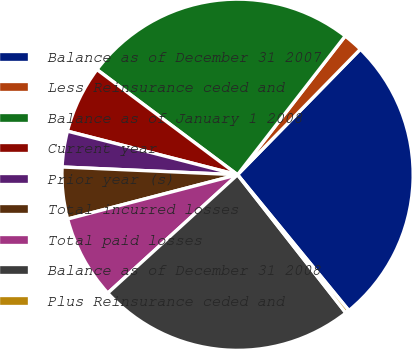Convert chart to OTSL. <chart><loc_0><loc_0><loc_500><loc_500><pie_chart><fcel>Balance as of December 31 2007<fcel>Less Reinsurance ceded and<fcel>Balance as of January 1 2008<fcel>Current year<fcel>Prior year (s)<fcel>Total incurred losses<fcel>Total paid losses<fcel>Balance as of December 31 2008<fcel>Plus Reinsurance ceded and<nl><fcel>26.75%<fcel>1.82%<fcel>25.28%<fcel>6.23%<fcel>3.29%<fcel>4.76%<fcel>7.71%<fcel>23.81%<fcel>0.35%<nl></chart> 